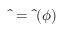Convert formula to latex. <formula><loc_0><loc_0><loc_500><loc_500>\hat { \Phi } = \hat { \Phi } ( \phi )</formula> 